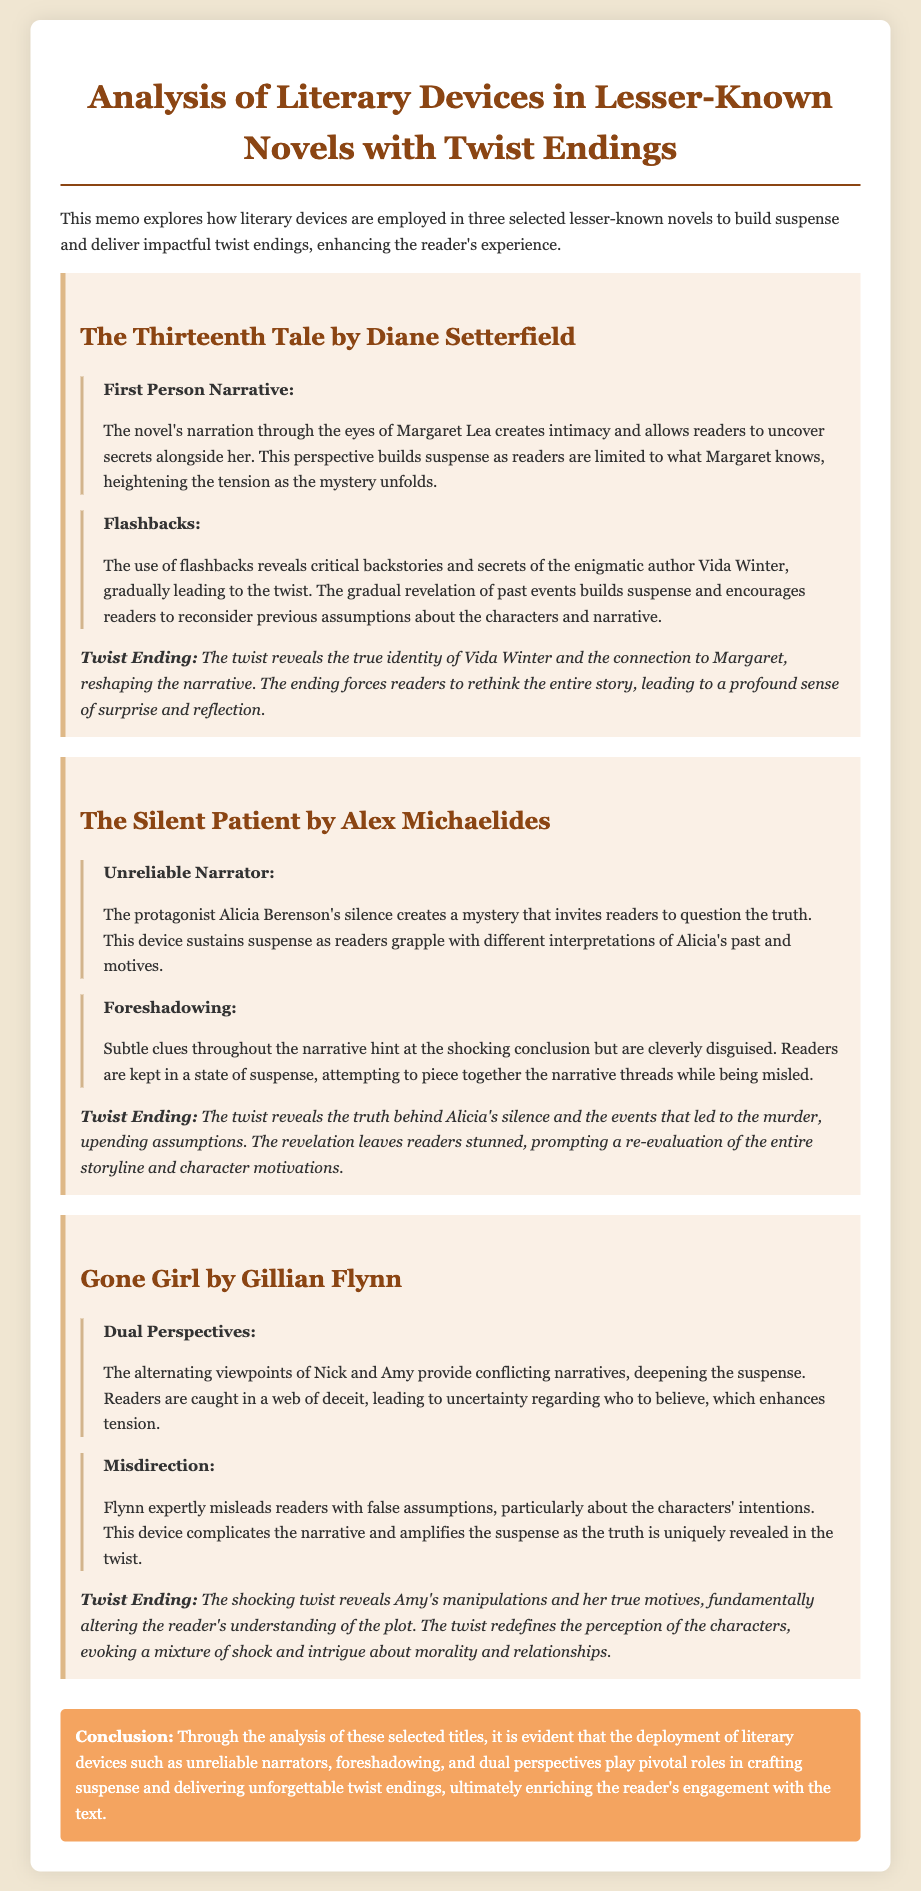What is the title of the first book analyzed? The first book analyzed in the memo is explicitly stated as "The Thirteenth Tale by Diane Setterfield."
Answer: The Thirteenth Tale by Diane Setterfield How many literary devices are discussed for "The Silent Patient"? The document points out the discussion of two literary devices related to "The Silent Patient": the unreliable narrator and foreshadowing.
Answer: Two What type of narrative is used in "The Thirteenth Tale"? The document mentions that "The Thirteenth Tale" employs a first-person narrative, which is highlighted in the description.
Answer: First Person Narrative What does the twist ending of "Gone Girl" reveal? The memo describes that the twist ending of "Gone Girl" unveils Amy's manipulations and her true motives, highlighting the significance of the plot twist.
Answer: Amy's manipulations What literary device creates suspense through character perspectives in "Gone Girl"? The memo refers to dual perspectives as the literary device that increases suspense in "Gone Girl" by presenting conflicting narratives.
Answer: Dual Perspectives How is the suspense built in "The Silent Patient"? According to the document, suspense in "The Silent Patient" is built through the use of an unreliable narrator, creating mystery and inviting doubts.
Answer: Unreliable Narrator What is the conclusion about literary devices in the analysis? The conclusion summarizes that literary devices such as unreliable narrators and foreshadowing significantly enhance suspense and reader engagement with the texts.
Answer: Enriching reader's engagement What impact does the twist ending have on the reader in "The Thirteenth Tale"? The memo states that the twist ending in "The Thirteenth Tale" compels readers to reconsider the entire story, evoking surprise and reflection.
Answer: Profound sense of surprise and reflection 